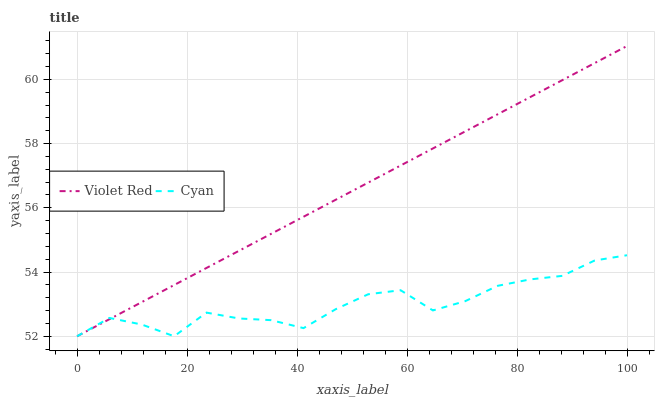Does Violet Red have the minimum area under the curve?
Answer yes or no. No. Is Violet Red the roughest?
Answer yes or no. No. 